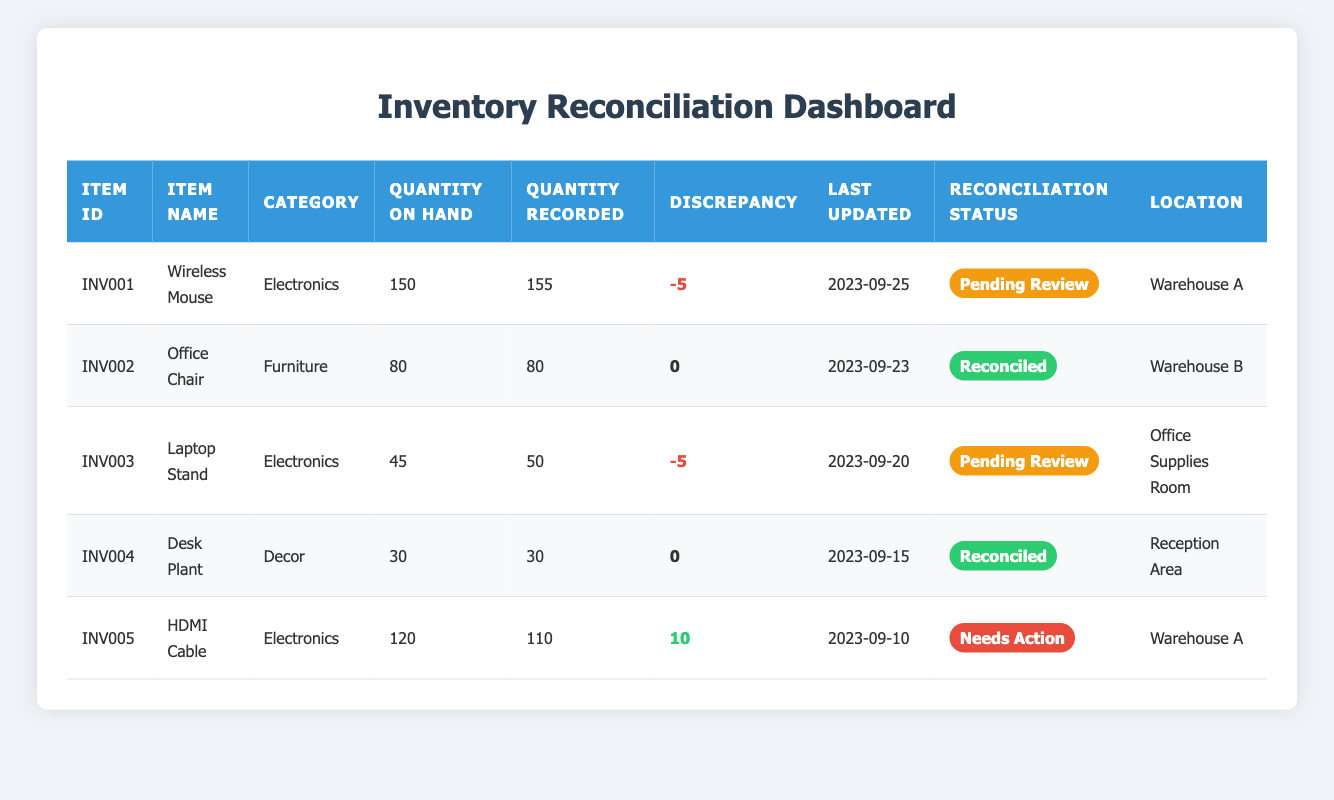What is the item ID of the Wireless Mouse? The table lists the Wireless Mouse under the ItemID column, which directly states that its ID is INV001.
Answer: INV001 How many Office Chairs are recorded in the inventory? The quantity recorded for the Office Chair is present in the Quantity Recorded column, which shows 80 for that item.
Answer: 80 What is the total discrepancy for all items in the inventory? To find the total discrepancy, sum the values from the Discrepancy column: -5 (for INV001) + 0 (for INV002) - 5 (for INV003) + 0 (for INV004) + 10 (for INV005) = 0.
Answer: 0 Is the HDMI Cable in need of action? The Reconciliation Status column for the HDMI Cable indicates "Needs Action," confirming that it is indeed in need of action.
Answer: Yes Which item has the highest quantity on hand? Reviewing the Quantity On Hand column, the Wireless Mouse has the highest value of 150 compared to other items which have 120, 80, 45, and 30, respectively.
Answer: Wireless Mouse How many items are currently pending review? By counting the rows with the Reconciliation Status of "Pending Review", we find there are 2 items (Wireless Mouse and Laptop Stand) that need further examination.
Answer: 2 What percentage of items have been reconciled? There are 5 items in total, and 2 of them are reconciled. To find the percentage, divide the reconciled items (2) by the total (5) and multiply by 100: (2/5) * 100 = 40%.
Answer: 40% What are the discrepancies for items in the Electronics category? Looking at the Electronics category, the Wireless Mouse has a discrepancy of -5, and the HDMI Cable has a discrepancy of 10. Adding these gives a total of 5 (the negative count should be considered).
Answer: 5 Which item is located in the Reception Area? The table shows that the Desk Plant is the item located in the Reception Area, as stated in the Location column.
Answer: Desk Plant 